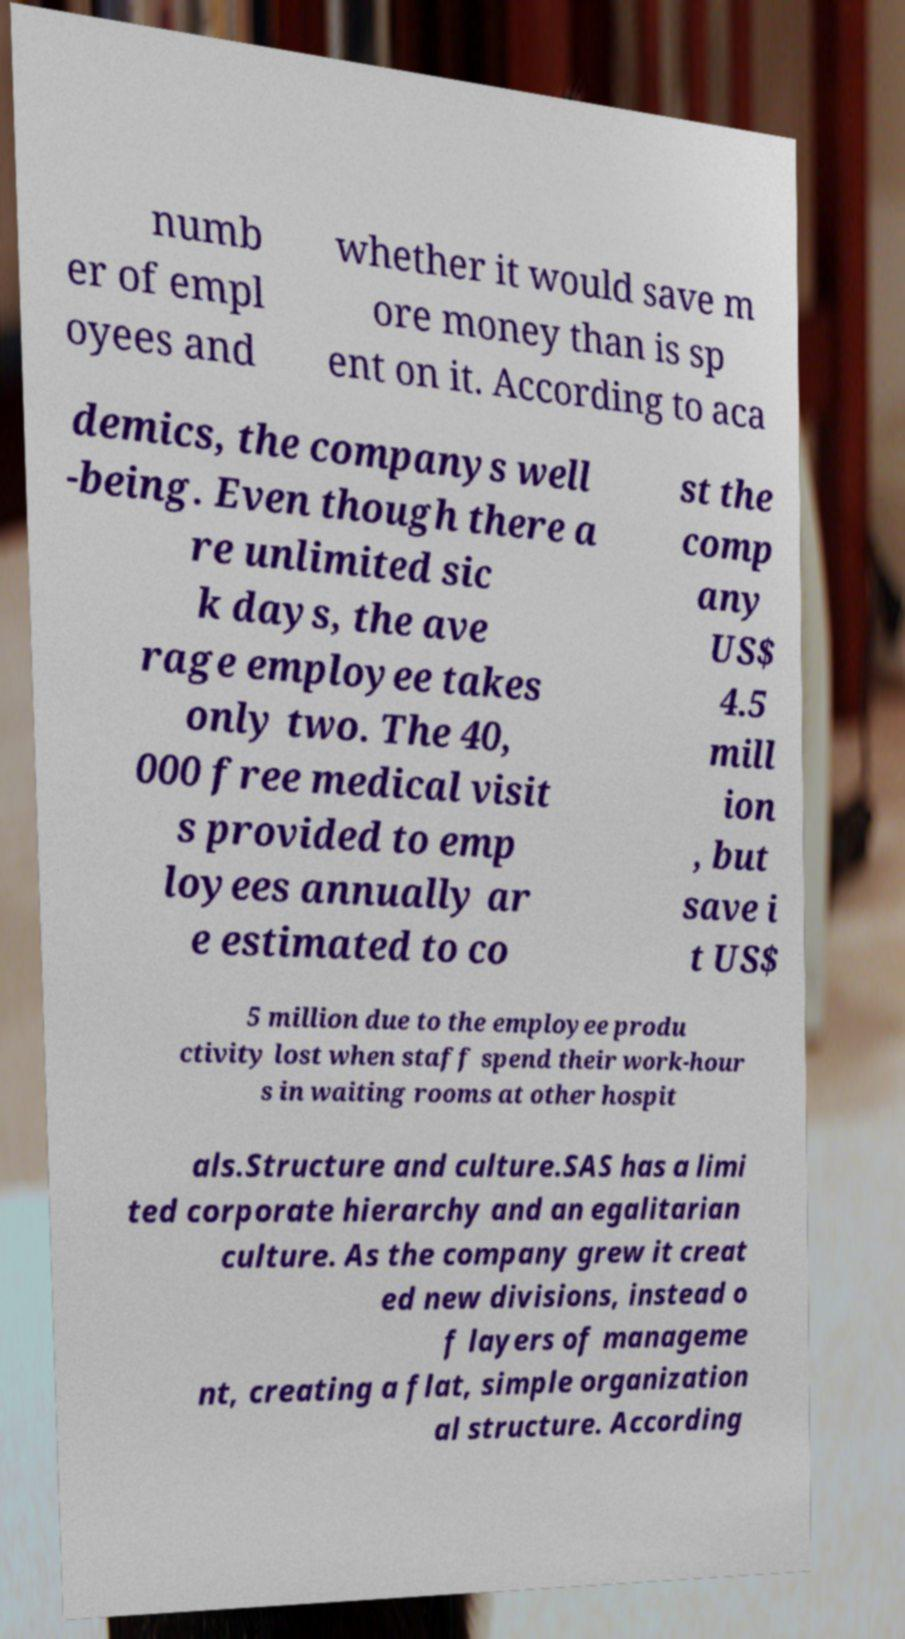What messages or text are displayed in this image? I need them in a readable, typed format. numb er of empl oyees and whether it would save m ore money than is sp ent on it. According to aca demics, the companys well -being. Even though there a re unlimited sic k days, the ave rage employee takes only two. The 40, 000 free medical visit s provided to emp loyees annually ar e estimated to co st the comp any US$ 4.5 mill ion , but save i t US$ 5 million due to the employee produ ctivity lost when staff spend their work-hour s in waiting rooms at other hospit als.Structure and culture.SAS has a limi ted corporate hierarchy and an egalitarian culture. As the company grew it creat ed new divisions, instead o f layers of manageme nt, creating a flat, simple organization al structure. According 